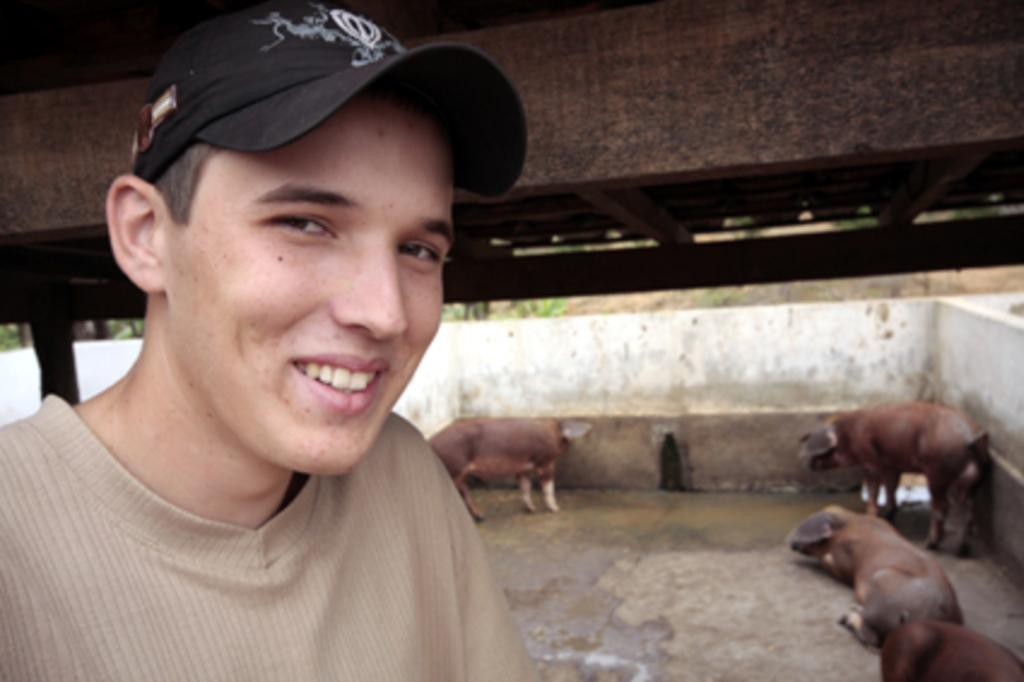Who or what is present in the image? There is a person in the image. What is the person wearing? The person is wearing clothes and a cap. What else can be seen in the image besides the person? There are animals in the image. Where are the animals located in relation to other elements in the image? The animals are beside a wall. What type of treatment is the person receiving for their cap in the image? There is no indication in the image that the person is receiving any treatment for their cap. 